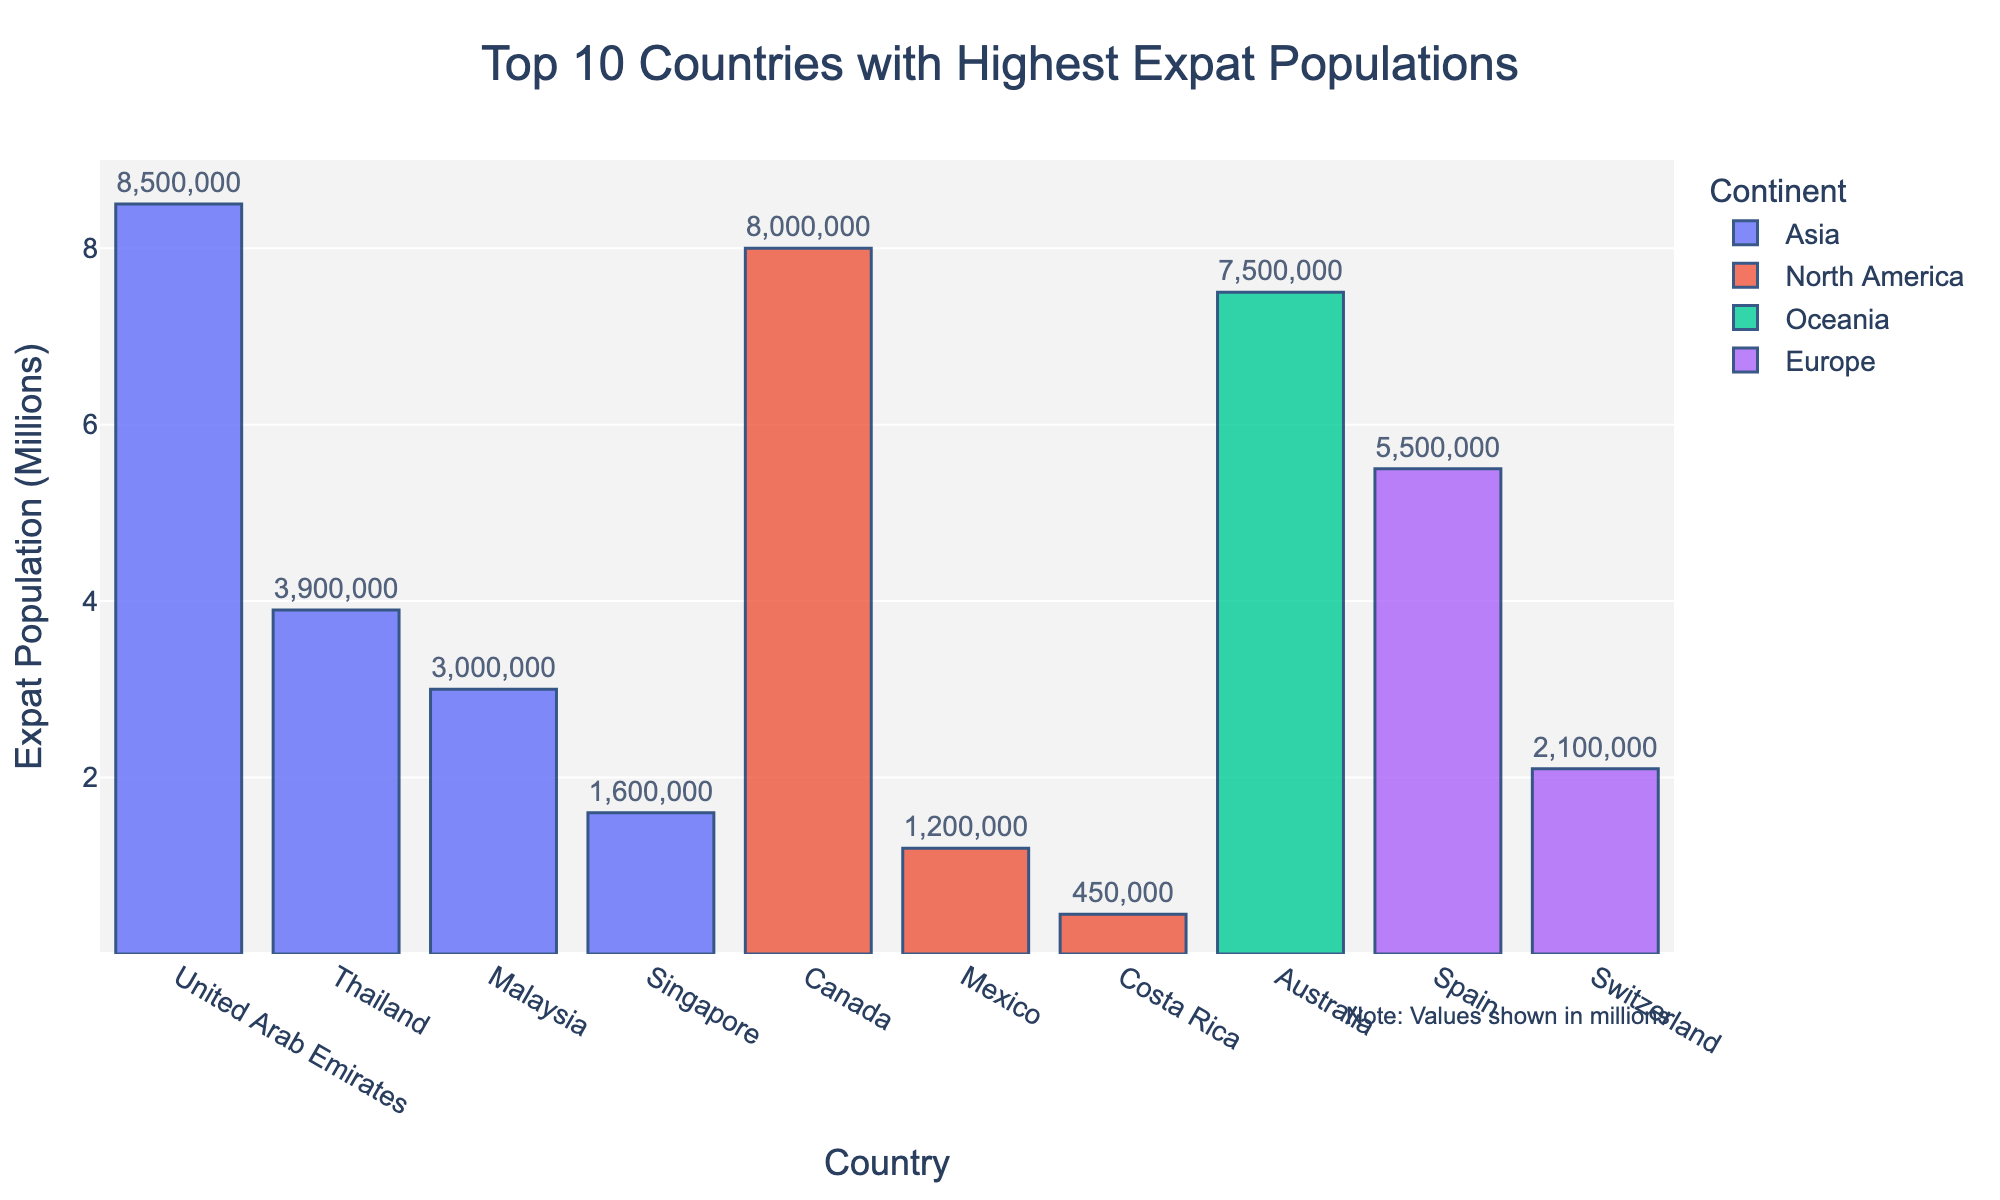Which country has the highest expat population? The tallest bar represents the country with the highest expat population. The tallest bar belongs to the United Arab Emirates.
Answer: United Arab Emirates What is the total expat population in the top 3 countries? The top 3 countries by expat population are United Arab Emirates, Canada, and Australia with populations of 8,500,000, 8,000,000, and 7,500,000 respectively. Summing these values gives 8,500,000 + 8,000,000 + 7,500,000 = 24,000,000.
Answer: 24,000,000 Which continent is represented by the most countries in the top 10 list? By counting the number of countries from each continent, Asia has 4 countries (United Arab Emirates, Singapore, Malaysia, Thailand), Europe has 2 countries (Switzerland, Spain), North America has 3 countries (Canada, Mexico, Costa Rica), and Oceania has 1 country (Australia). The continent with the most countries represented is Asia.
Answer: Asia How much higher is the expat population of Spain compared to Mexico? The expat population in Spain is 5,500,000 and in Mexico is 1,200,000. The difference is 5,500,000 - 1,200,000 = 4,300,000.
Answer: 4,300,000 What is the average expat population of the European countries in the top 10 list? The European countries in the top 10 list are Switzerland and Spain with expat populations of 2,100,000 and 5,500,000 respectively. The average is calculated as (2,100,000 + 5,500,000) / 2 = 3,800,000.
Answer: 3,800,000 Which country in North America has the lowest expat population? The bars representing North American countries are Canada, Mexico, and Costa Rica. Among these, Costa Rica has the shortest bar, indicating the lowest expat population.
Answer: Costa Rica What is the combined expat population of all Asian countries in the top 10 list? The Asian countries listed are United Arab Emirates, Singapore, Malaysia, and Thailand with expat populations of 8,500,000, 1,600,000, 3,000,000, and 3,900,000 respectively. Adding these gives 8,500,000 + 1,600,000 + 3,000,000 + 3,900,000 = 17,000,000.
Answer: 17,000,000 